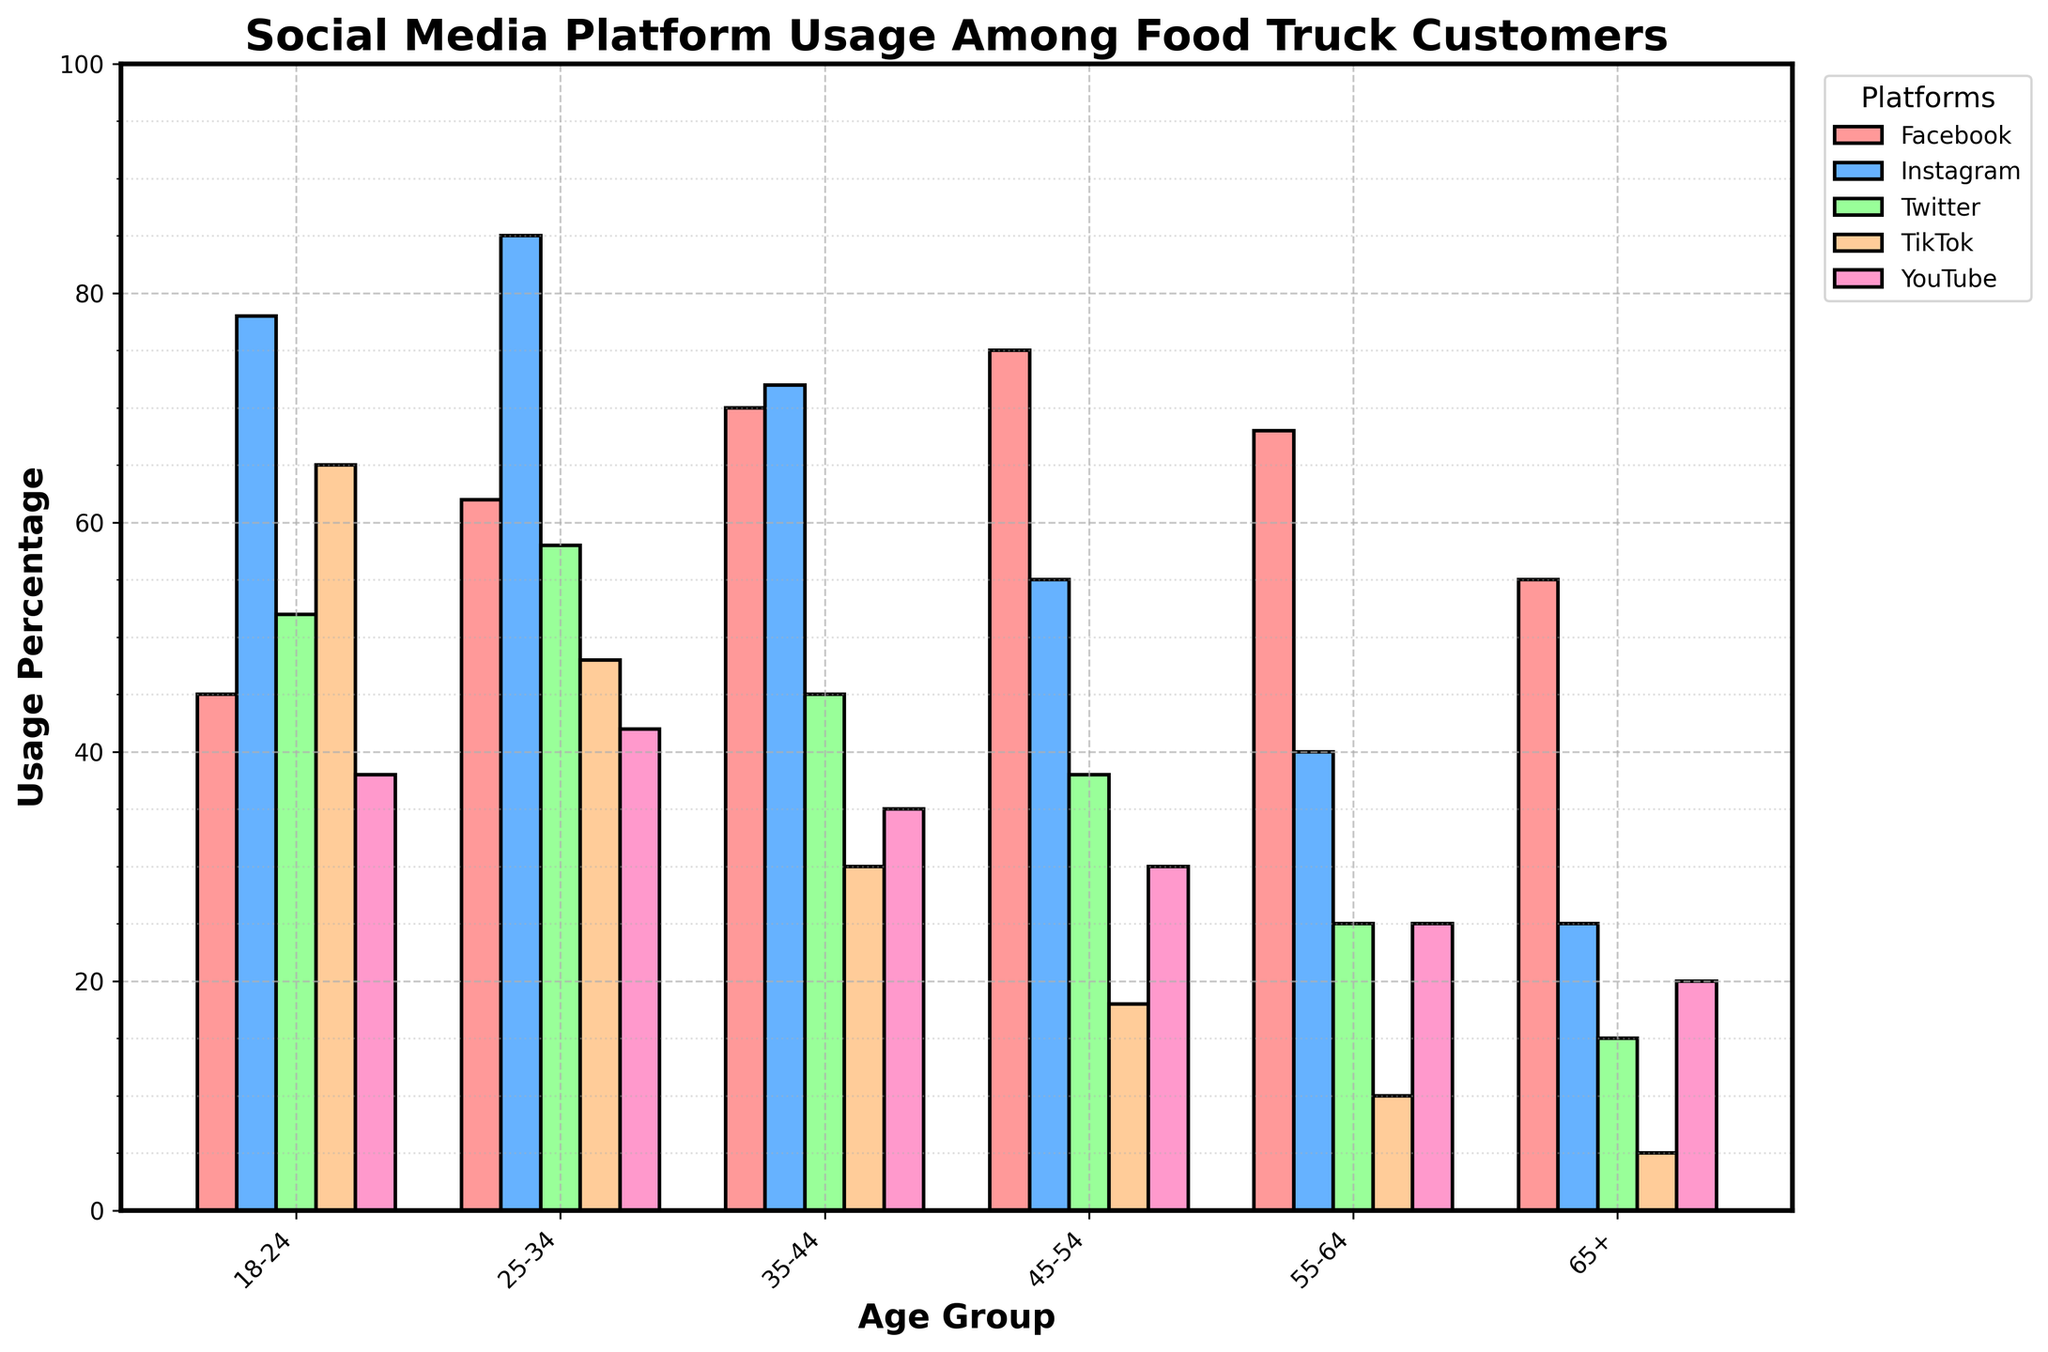What age group has the highest usage percentage on Facebook? Look at the bar heights for Facebook across different age groups. The highest bar for Facebook is in the 45-54 age group.
Answer: 45-54 Which social media platform has the lowest usage among the 65+ age group? For the 65+ age group, compare the bars for all platforms. The smallest bar is for TikTok.
Answer: TikTok What is the total combined usage percentage of Instagram and Twitter for the 25-34 age group? Add the usage percentages of Instagram (85) and Twitter (58) for the 25-34 age group. 85 + 58 = 143
Answer: 143 How does TikTok usage in the 18-24 age group compare to TikTok usage in the 35-44 age group? Compare the heights of the TikTok bars for the 18-24 and 35-44 age groups. 18-24 has a higher bar (65) than 35-44 (30).
Answer: 18-24 > 35-44 Which age group has a higher social media usage on YouTube, 45-54 or 55-64? Look at the bars for YouTube in the 45-54 and 55-64 age groups. The 45-54 group's bar is higher (30) compared to the 55-64 group's bar (25).
Answer: 45-54 What is the average usage percentage of Facebook across all age groups? Sum the Facebook usage percentages across all age groups and divide by the number of age groups. (45 + 62 + 70 + 75 + 68 + 55) / 6 = 375 / 6 ≈ 62.5
Answer: 62.5 Which social media platform shows a steady decline in usage as age increases? Check the trend of the bars for each platform. TikTok shows a clear decreasing trend from younger to older age groups.
Answer: TikTok What’s the difference in Instagram usage between the 18-24 and 25-34 age groups? Subtract the Instagram usage of the 18-24 age group (78) from the 25-34 age group (85). 85 - 78 = 7
Answer: 7 Which age group has the lowest overall social media usage combined? Add the usage percentages for all platforms across each age group and compare. The smallest total is for the 65+ group (55 + 25 + 15 + 5 + 20 = 120).
Answer: 65+ 